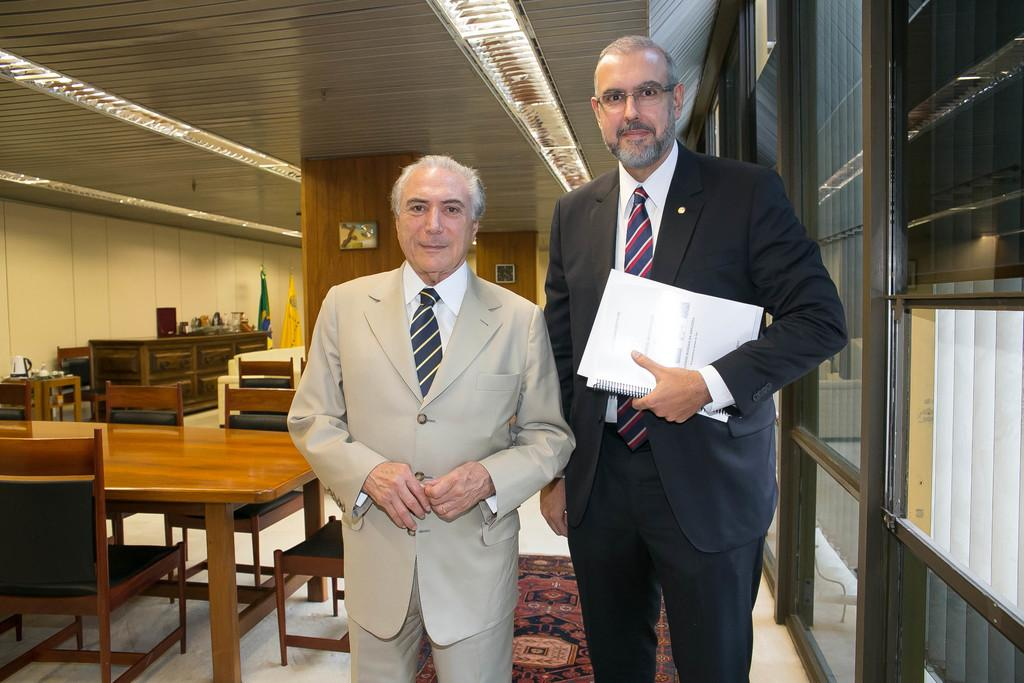What type of furniture is present in the room? There are tables and chairs in the room. What are the men in the room doing? The two men standing in the room are holding papers. What day of the week is it in the image? The day of the week is not mentioned or depicted in the image. How much money are the men holding in the image? The men are holding papers, not money, in the image. 